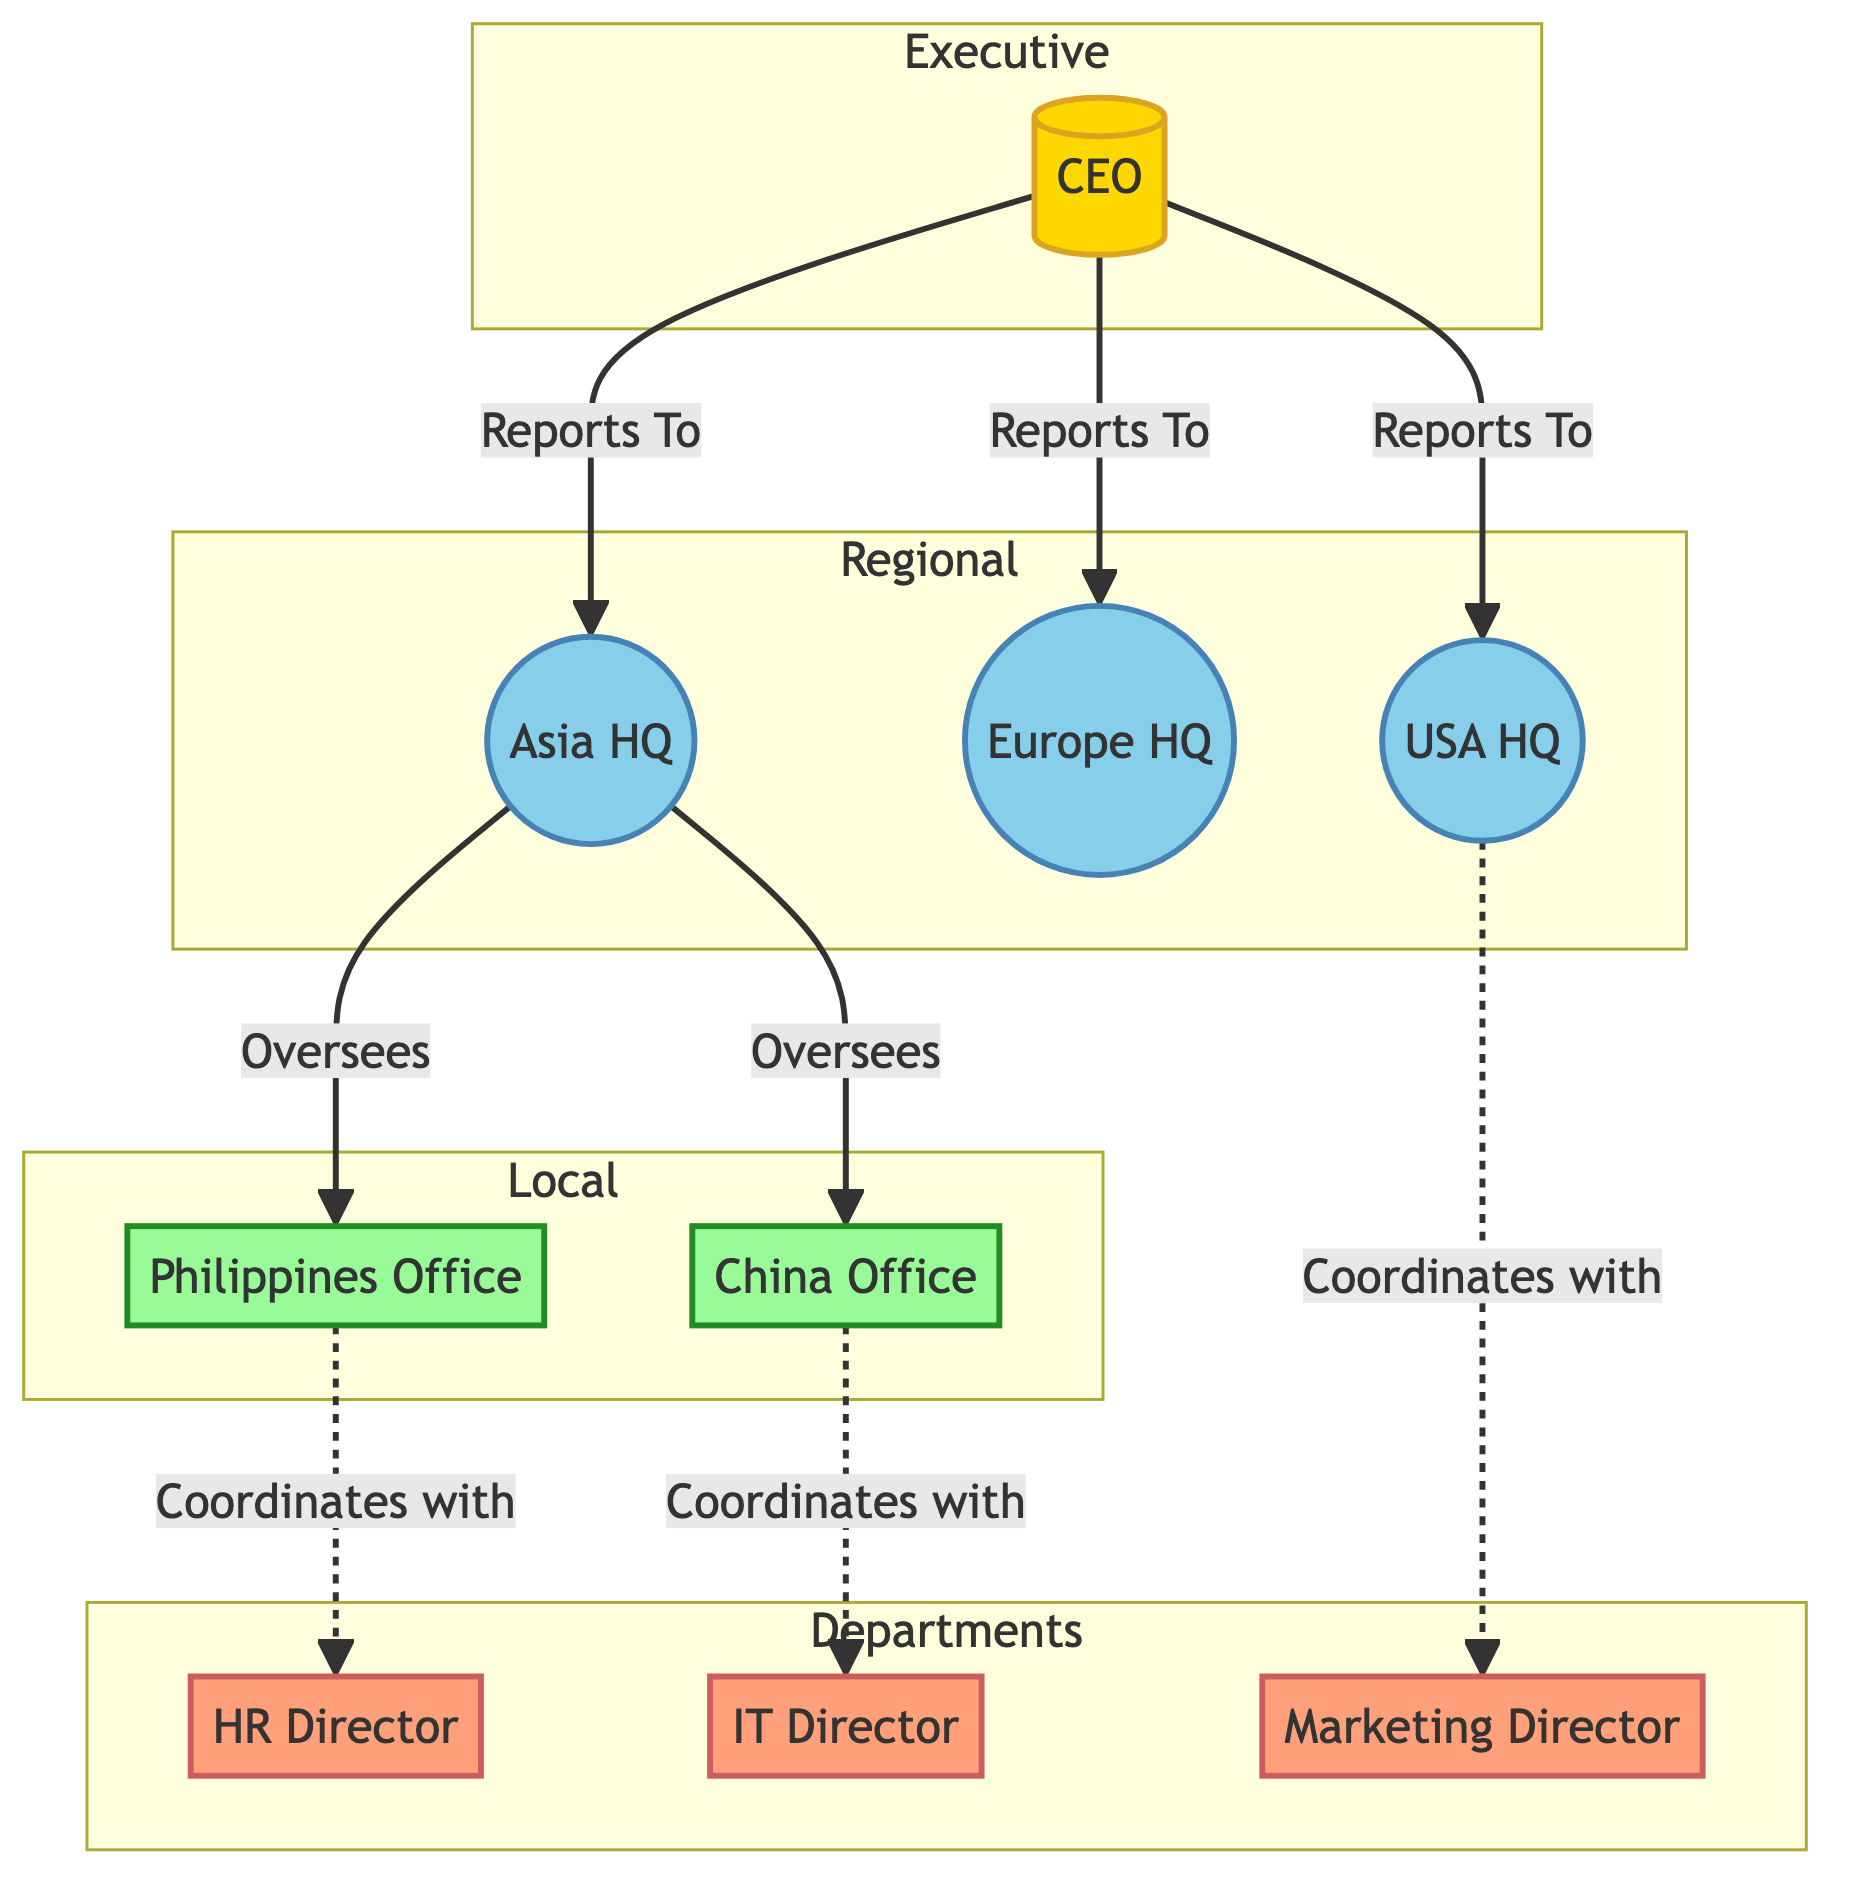What is the top management position in the diagram? The diagram identifies the node labeled "CEO" as the top management position, defined under "Executive Management."
Answer: CEO How many regional headquarters are represented in the diagram? There are three regional headquarters represented: Asia Headquarters, Europe Headquarters, and USA Headquarters, which can be counted among the nodes defined in the Regional category.
Answer: 3 Which local office oversees the China Office? According to the diagram, the Asia Headquarters oversees the China Office, as indicated by the edge labeled "Oversees" between AsiaHQ and ChinaOffice.
Answer: Asia Headquarters Who coordinates with the Philippines Office? The diagram indicates that the HR Director coordinates with the Philippines Office, represented by the edge labeled "Coordinates with" from PhilippinesOffice to HRDirector.
Answer: HR Director Which region is the CEO associated with in terms of reporting? The CEO reports to three regional headquarters: Asia Headquarters, Europe Headquarters, and USA Headquarters, as shown by the edges labeled "Reports To" leading from the CEO to each region.
Answer: Asia Headquarters, Europe Headquarters, USA Headquarters What type of relationship exists between the USA Headquarters and the Marketing Director? There is a coordinating relationship between the USA Headquarters and Marketing Director, depicted by the edge labeled "Coordinates with" from USAHQ to MarketingDirector.
Answer: Coordinates with How many local offices are present in the diagram? The diagram shows two local offices: Philippines Office and China Office, which can be identified under the Local category of nodes.
Answer: 2 What is the primary function of the HR Director in relation to the local office? The HR Director has a coordinating function with the Philippines Office, as shown by the edge labeled "Coordinates with" that connects the PhilippinesOffice to HRDirector.
Answer: Coordinates with Which regional management oversees the local offices? The Asia Headquarters oversees both the Philippines Office and the China Office, indicated by the edges labeled "Oversees" leading from AsiaHQ to both local offices.
Answer: Asia Headquarters 